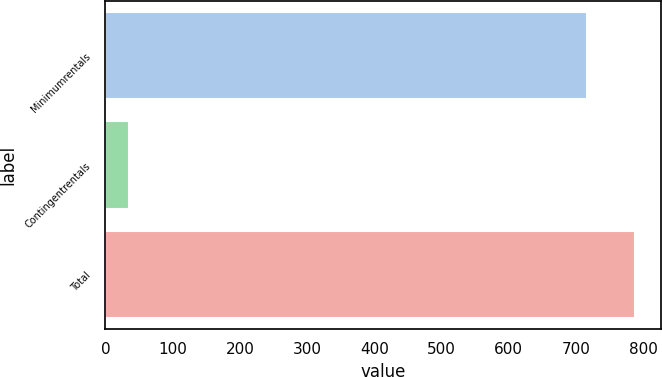<chart> <loc_0><loc_0><loc_500><loc_500><bar_chart><fcel>Minimumrentals<fcel>Contingentrentals<fcel>Total<nl><fcel>715.6<fcel>34.3<fcel>787.16<nl></chart> 